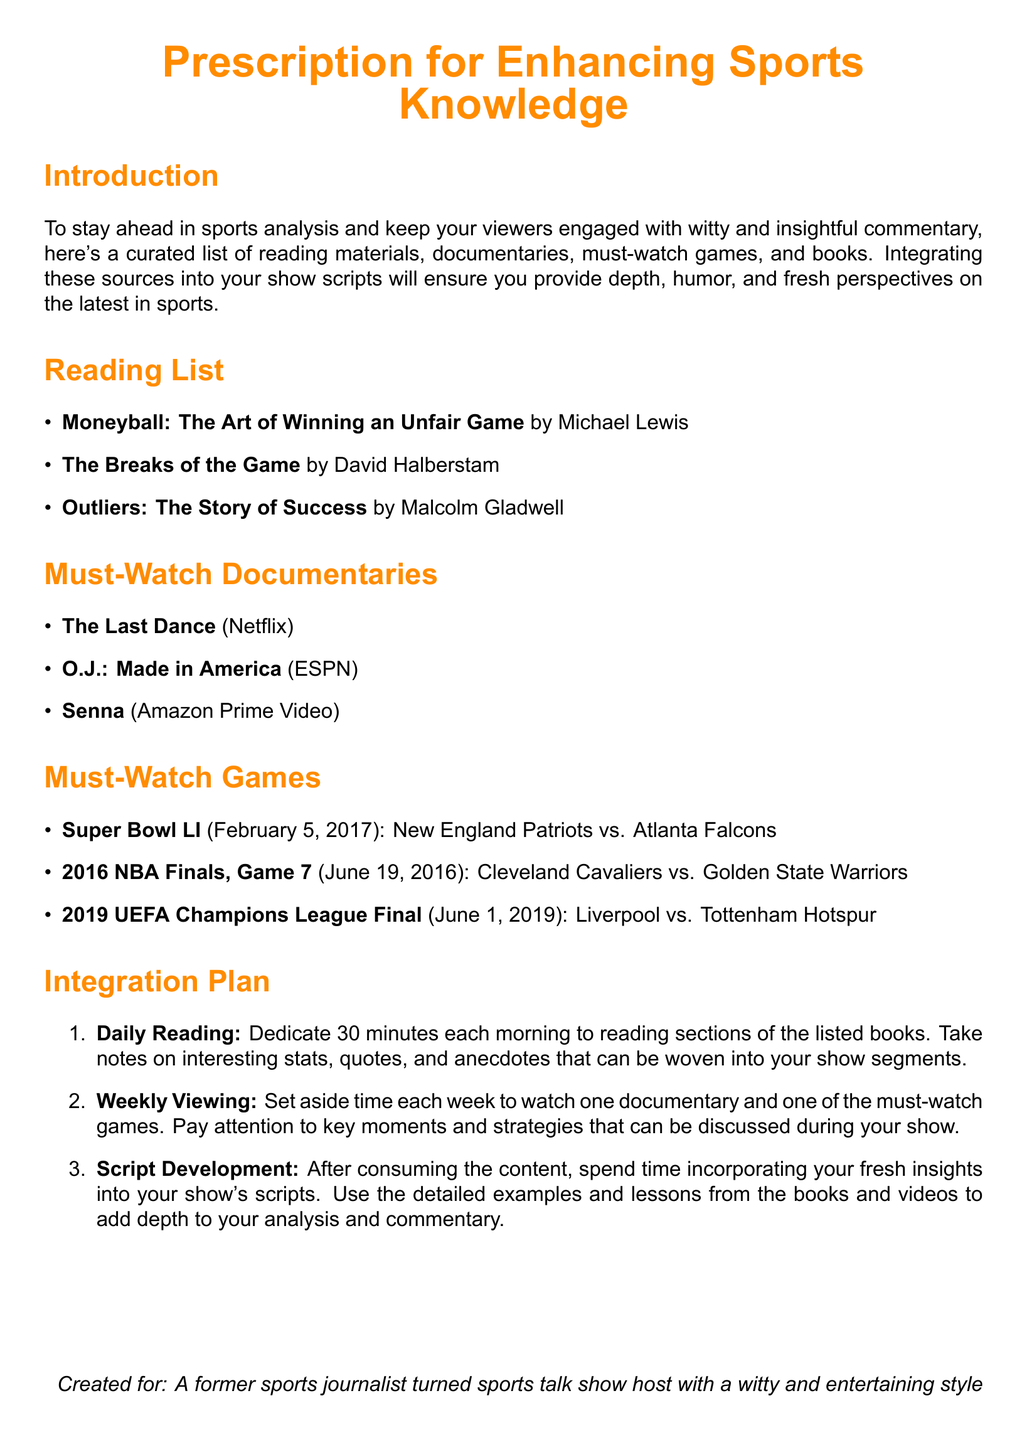What is the title of the first book in the reading list? The title of the first book is listed as the first entry in the Reading List section of the document.
Answer: Moneyball: The Art of Winning an Unfair Game How many must-watch games are listed? The number of must-watch games can be found by counting the entries in the Must-Watch Games section.
Answer: 3 What is the last must-watch documentary mentioned? The last entry in the Must-Watch Documentaries section gives the title of the final documentary.
Answer: Senna What is the date of the Super Bowl LI? The date of the Super Bowl is specified in the Must-Watch Games section as the date of that particular event.
Answer: February 5, 2017 What time duration is suggested for daily reading? The time duration is provided in the Integration Plan section for daily reading.
Answer: 30 minutes Which book is authored by Malcolm Gladwell? The document mentions the author for each book in the Reading List section, identifying the specific book by that author.
Answer: Outliers: The Story of Success What is the title of the second game in the must-watch games list? The second game entry can be identified from the specific order in the Must-Watch Games section of the document.
Answer: 2016 NBA Finals, Game 7 How many documentaries are suggested to watch weekly? The document specifies a weekly viewing schedule in the Integration Plan section, indicating the number of documentaries.
Answer: 1 